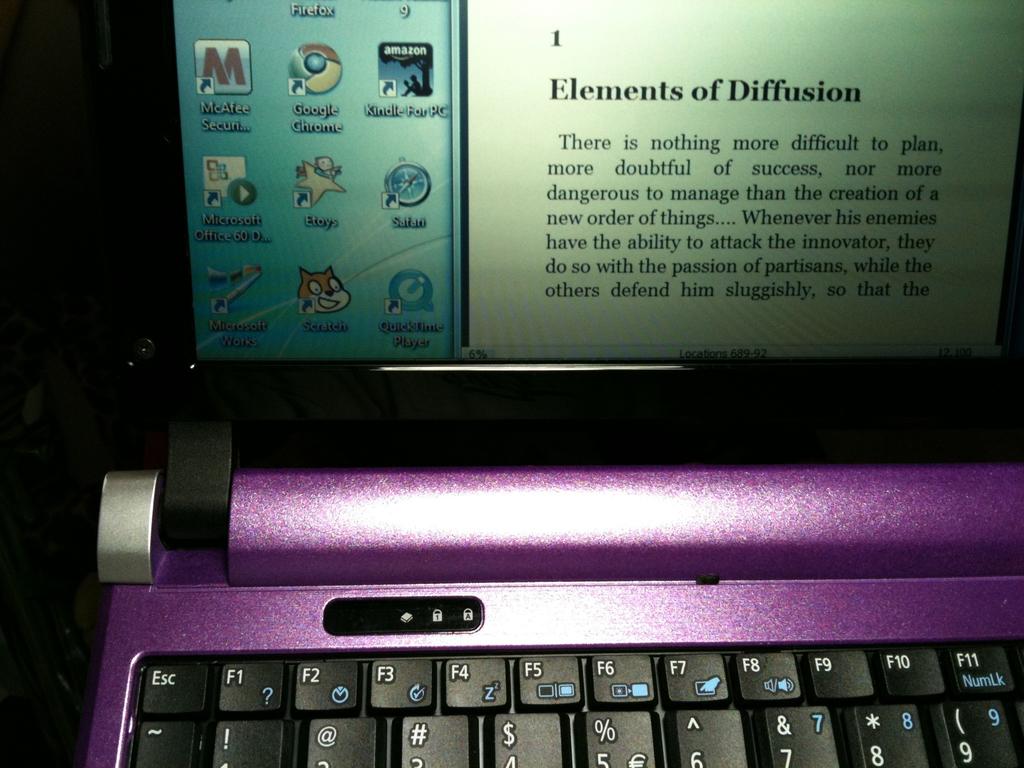Does this talk about elements of diffusion?
Provide a short and direct response. Yes. 